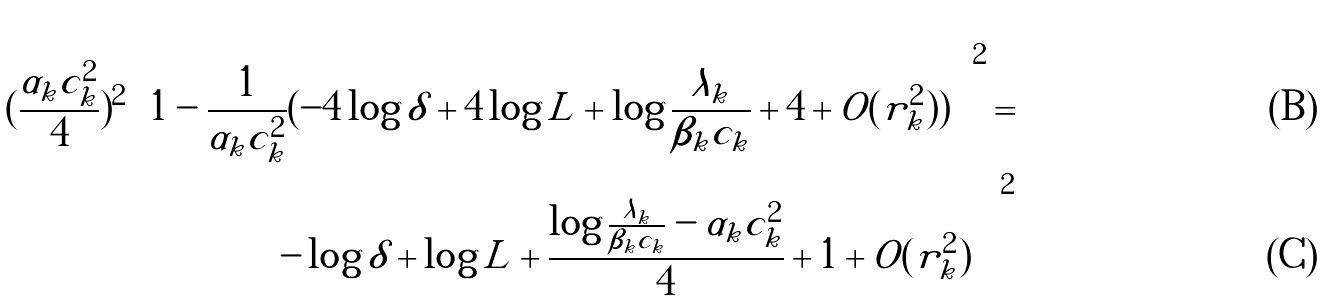Convert formula to latex. <formula><loc_0><loc_0><loc_500><loc_500>( \frac { \alpha _ { k } c _ { k } ^ { 2 } } { 4 } ) ^ { 2 } \left ( 1 - \frac { 1 } { \alpha _ { k } c _ { k } ^ { 2 } } ( - 4 \log \delta + 4 \log L + \log \frac { \lambda _ { k } } { \beta _ { k } c _ { k } } + 4 + O ( r _ { k } ^ { 2 } ) ) \right ) ^ { 2 } = \\ \left ( - \log \delta + \log L + \frac { \log \frac { \lambda _ { k } } { \beta _ { k } c _ { k } } - \alpha _ { k } c _ { k } ^ { 2 } } { 4 } + 1 + O ( r _ { k } ^ { 2 } ) \right ) ^ { 2 }</formula> 